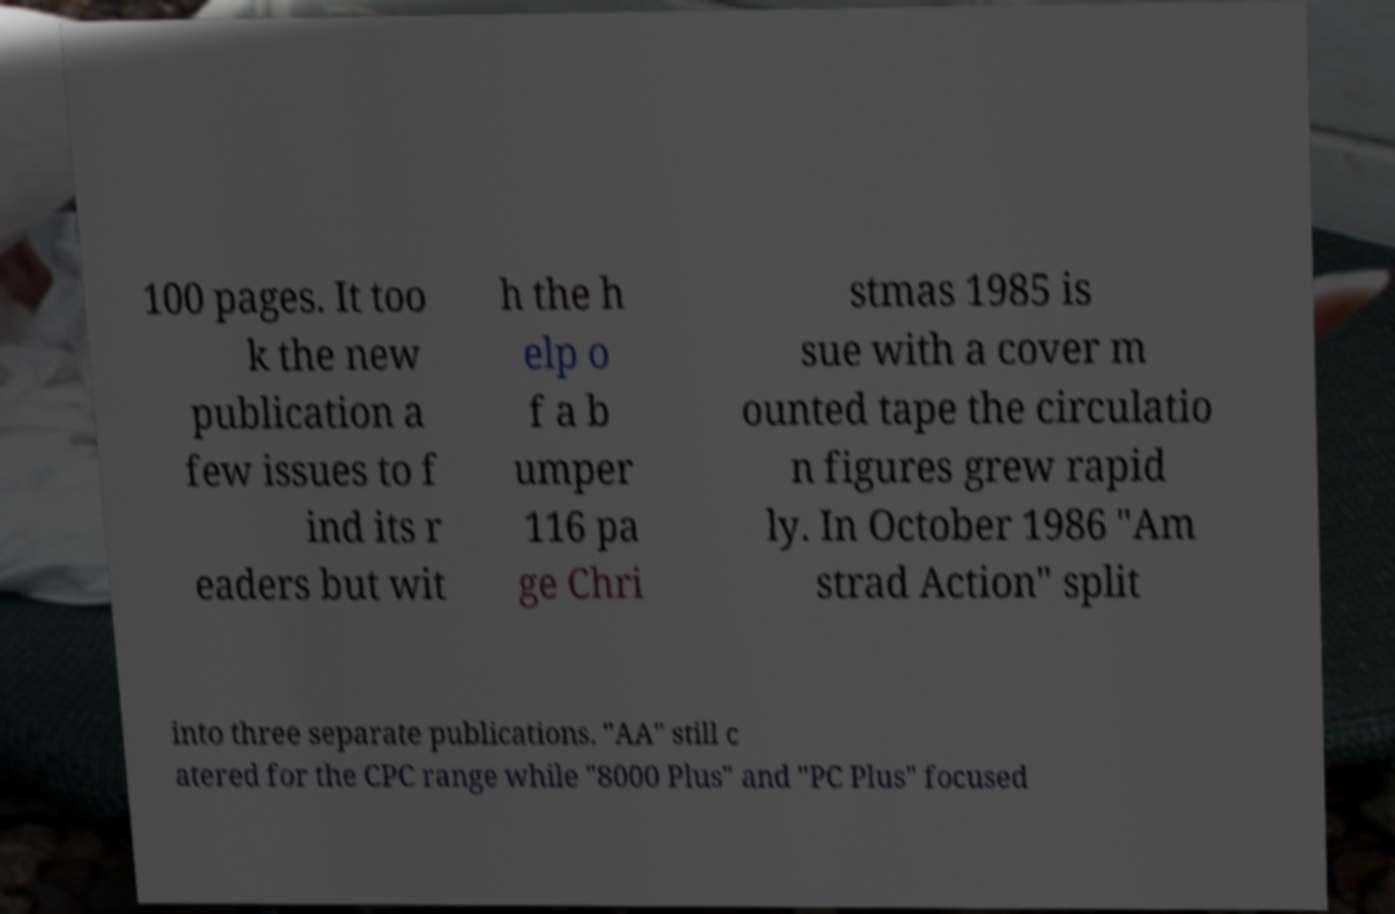Please read and relay the text visible in this image. What does it say? 100 pages. It too k the new publication a few issues to f ind its r eaders but wit h the h elp o f a b umper 116 pa ge Chri stmas 1985 is sue with a cover m ounted tape the circulatio n figures grew rapid ly. In October 1986 "Am strad Action" split into three separate publications. "AA" still c atered for the CPC range while "8000 Plus" and "PC Plus" focused 